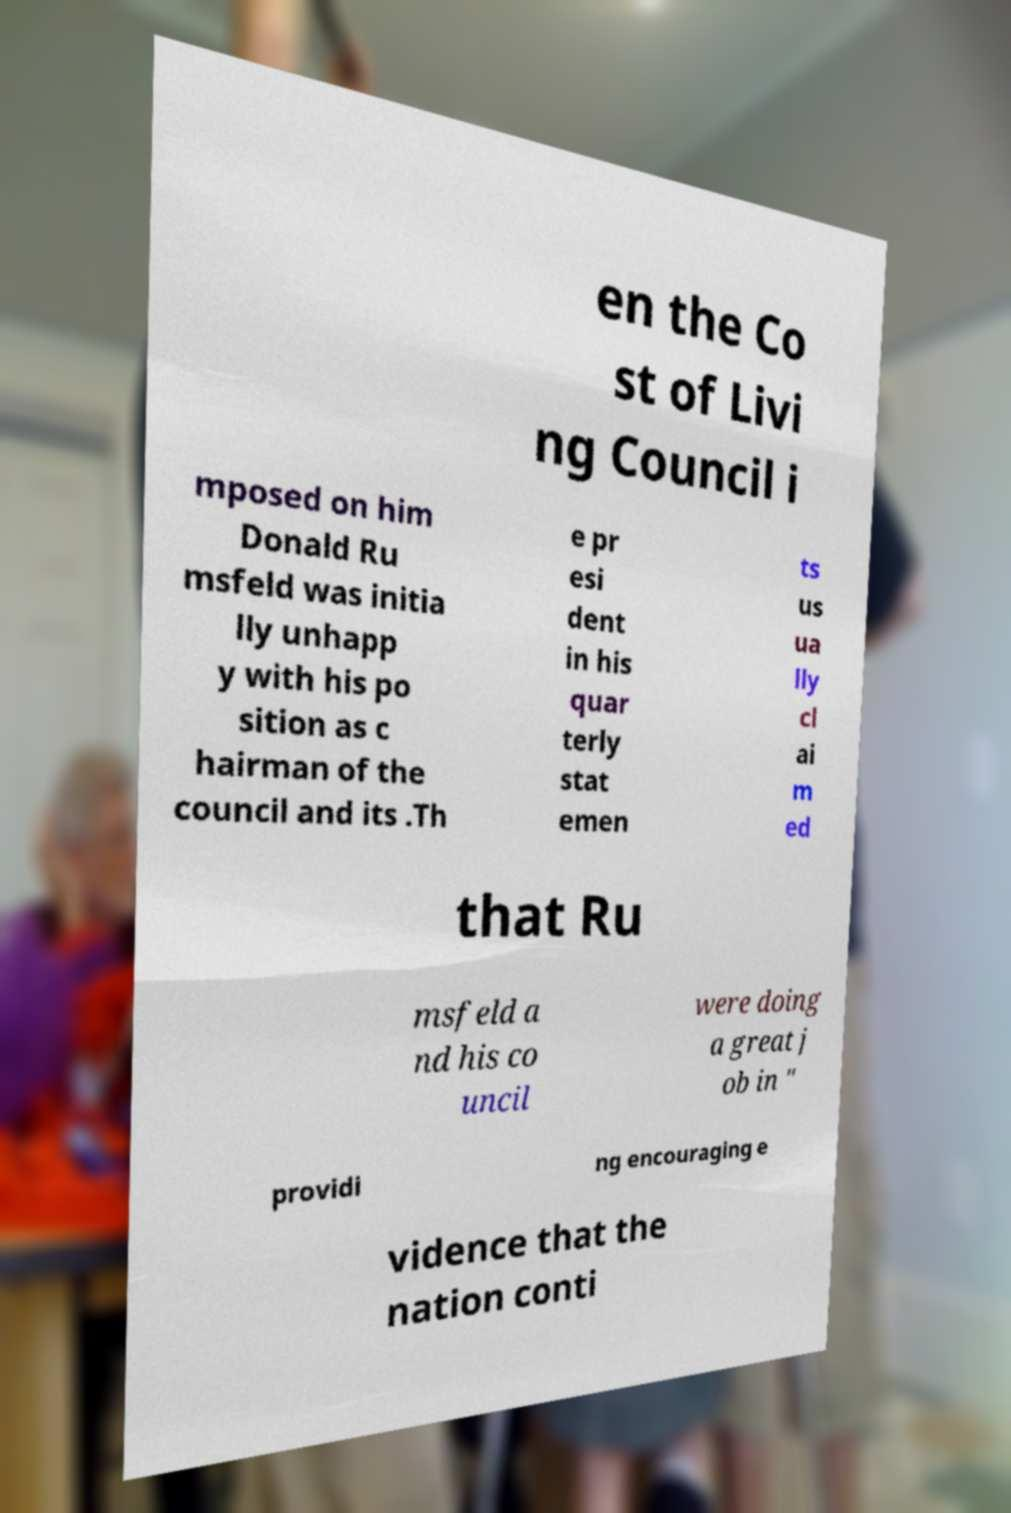What messages or text are displayed in this image? I need them in a readable, typed format. en the Co st of Livi ng Council i mposed on him Donald Ru msfeld was initia lly unhapp y with his po sition as c hairman of the council and its .Th e pr esi dent in his quar terly stat emen ts us ua lly cl ai m ed that Ru msfeld a nd his co uncil were doing a great j ob in " providi ng encouraging e vidence that the nation conti 